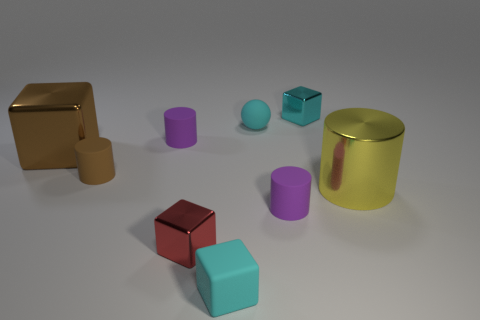Subtract 1 cylinders. How many cylinders are left? 3 Subtract all blocks. How many objects are left? 5 Subtract all small cyan metallic objects. Subtract all big cylinders. How many objects are left? 7 Add 6 yellow shiny objects. How many yellow shiny objects are left? 7 Add 7 brown metal cubes. How many brown metal cubes exist? 8 Subtract 0 gray blocks. How many objects are left? 9 